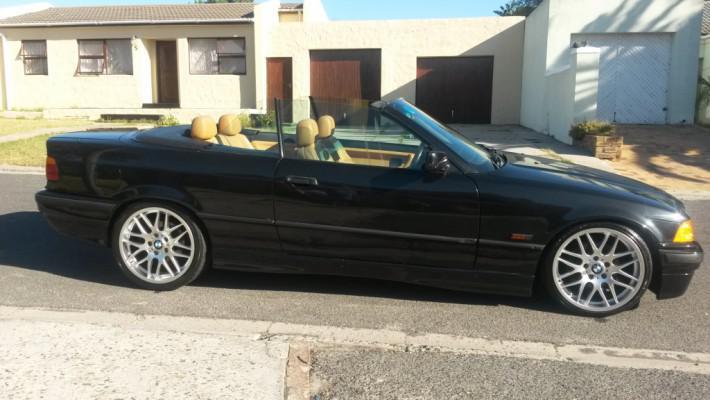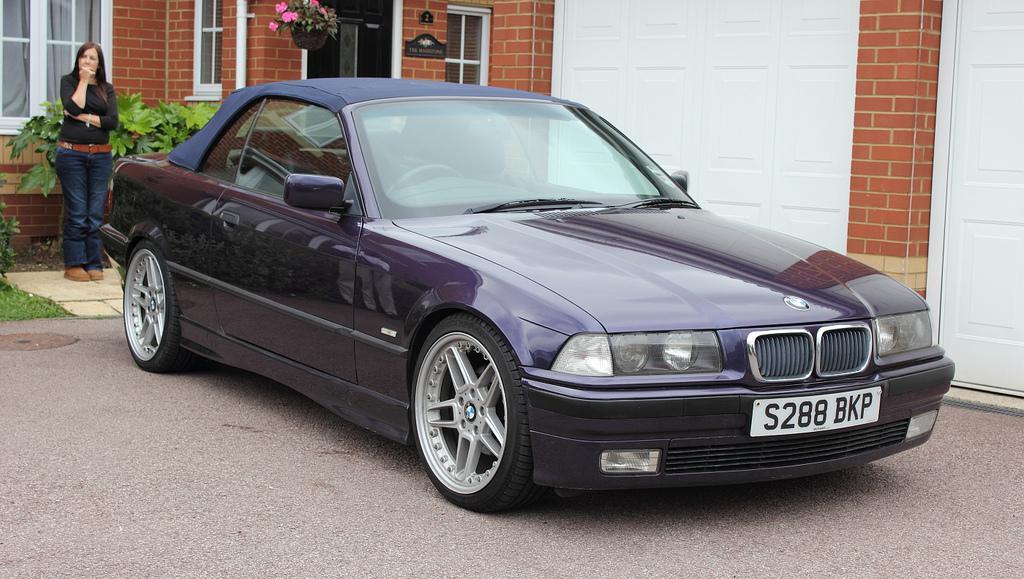The first image is the image on the left, the second image is the image on the right. Analyze the images presented: Is the assertion "There are two cars, but only one roof." valid? Answer yes or no. Yes. The first image is the image on the left, the second image is the image on the right. Analyze the images presented: Is the assertion "The car in the right image is facing towards the right." valid? Answer yes or no. Yes. 